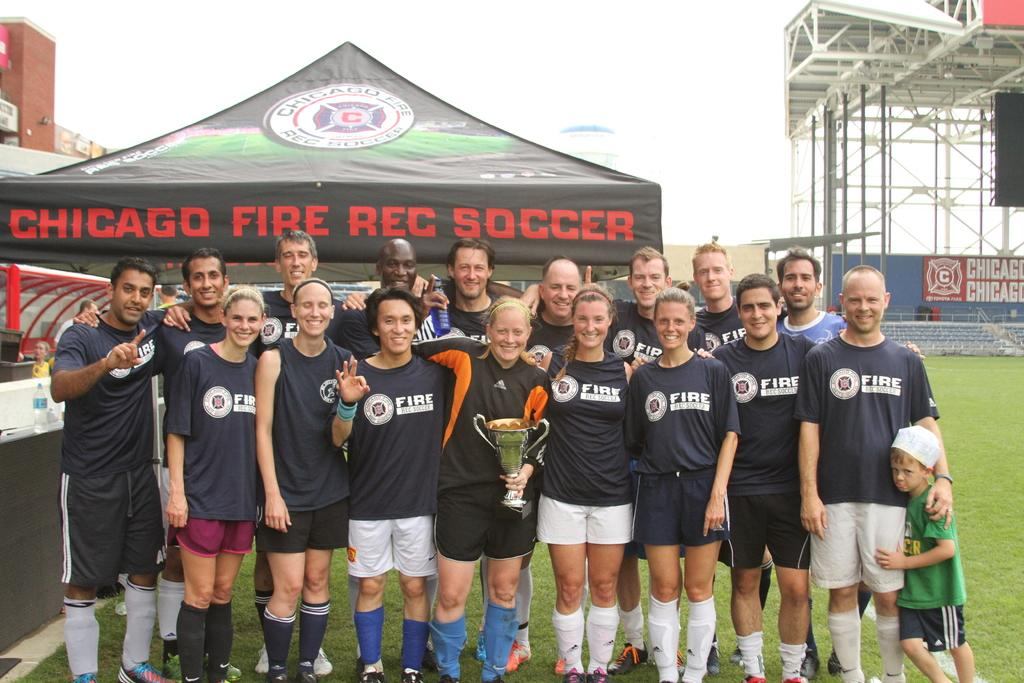<image>
Give a short and clear explanation of the subsequent image. people wearing FIRE shirts stand together for a portrait 